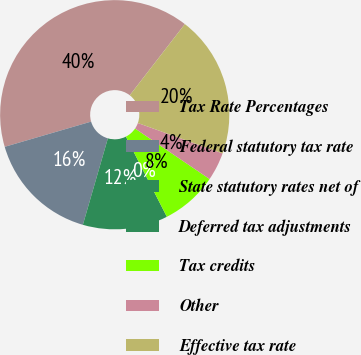Convert chart. <chart><loc_0><loc_0><loc_500><loc_500><pie_chart><fcel>Tax Rate Percentages<fcel>Federal statutory tax rate<fcel>State statutory rates net of<fcel>Deferred tax adjustments<fcel>Tax credits<fcel>Other<fcel>Effective tax rate<nl><fcel>40.0%<fcel>16.0%<fcel>12.0%<fcel>0.0%<fcel>8.0%<fcel>4.0%<fcel>20.0%<nl></chart> 